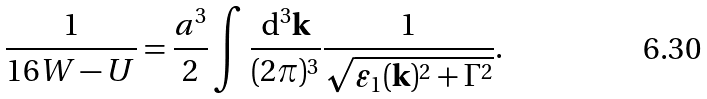Convert formula to latex. <formula><loc_0><loc_0><loc_500><loc_500>\frac { 1 } { 1 6 W - U } = \frac { a ^ { 3 } } { 2 } \int \frac { { \mathrm d } ^ { 3 } { \mathbf k } } { ( 2 \pi ) ^ { 3 } } \frac { 1 } { \sqrt { \varepsilon _ { 1 } ( { \mathbf k } ) ^ { 2 } + \Gamma ^ { 2 } } } .</formula> 